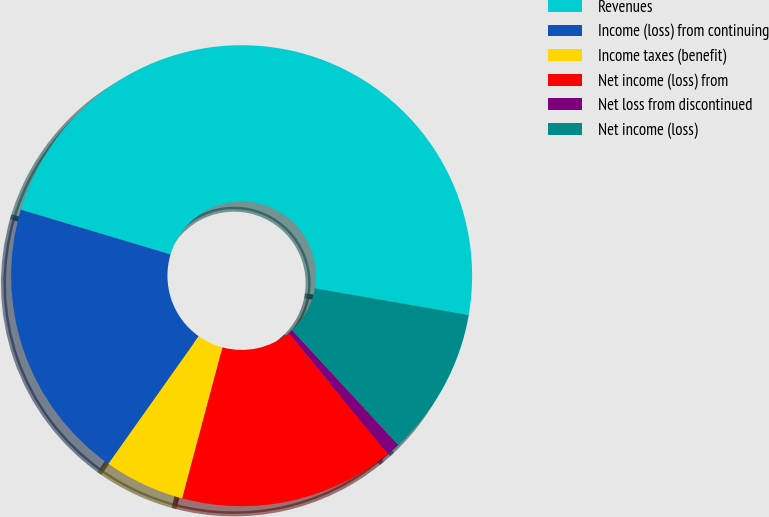Convert chart. <chart><loc_0><loc_0><loc_500><loc_500><pie_chart><fcel>Revenues<fcel>Income (loss) from continuing<fcel>Income taxes (benefit)<fcel>Net income (loss) from<fcel>Net loss from discontinued<fcel>Net income (loss)<nl><fcel>48.11%<fcel>19.81%<fcel>5.66%<fcel>15.09%<fcel>0.94%<fcel>10.38%<nl></chart> 